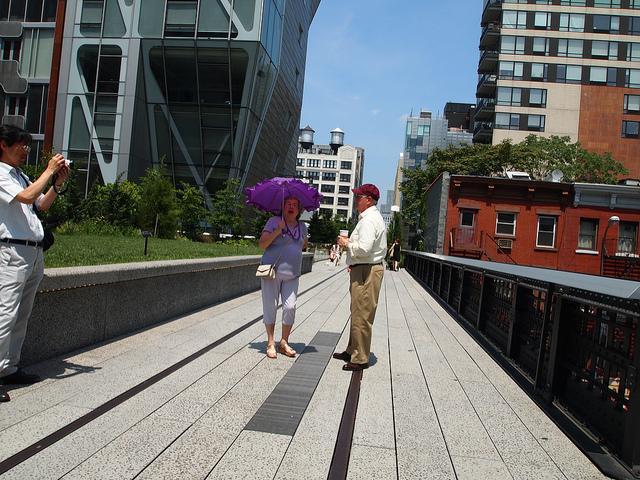How many people are there?
Give a very brief answer. 3. How many people are wearing orange vests?
Give a very brief answer. 0. 